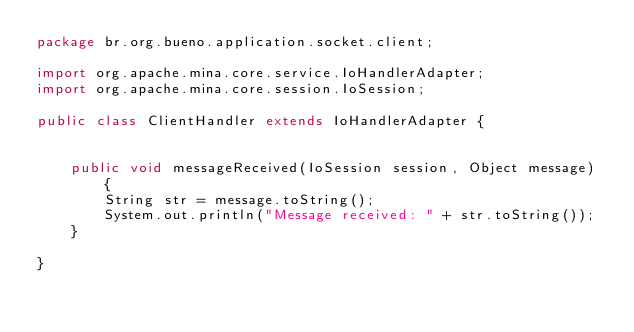Convert code to text. <code><loc_0><loc_0><loc_500><loc_500><_Java_>package br.org.bueno.application.socket.client;

import org.apache.mina.core.service.IoHandlerAdapter;
import org.apache.mina.core.session.IoSession;

public class ClientHandler extends IoHandlerAdapter {


	public void messageReceived(IoSession session, Object message) {
		String str = message.toString();
		System.out.println("Message received: " + str.toString());
	}

}
</code> 